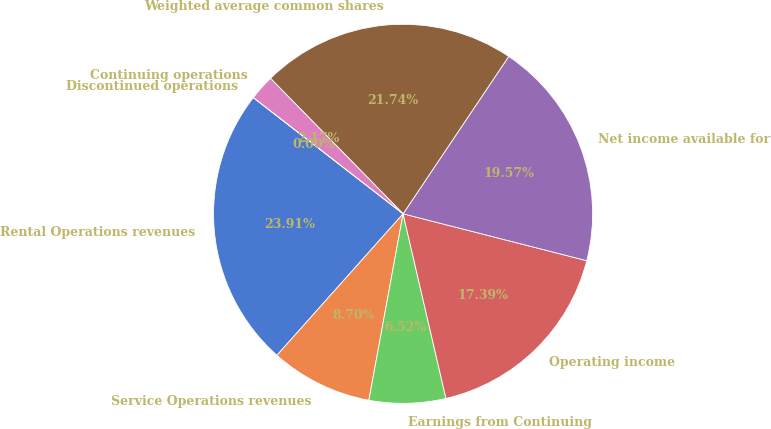Convert chart. <chart><loc_0><loc_0><loc_500><loc_500><pie_chart><fcel>Rental Operations revenues<fcel>Service Operations revenues<fcel>Earnings from Continuing<fcel>Operating income<fcel>Net income available for<fcel>Weighted average common shares<fcel>Continuing operations<fcel>Discontinued operations<nl><fcel>23.91%<fcel>8.7%<fcel>6.52%<fcel>17.39%<fcel>19.57%<fcel>21.74%<fcel>2.17%<fcel>0.0%<nl></chart> 